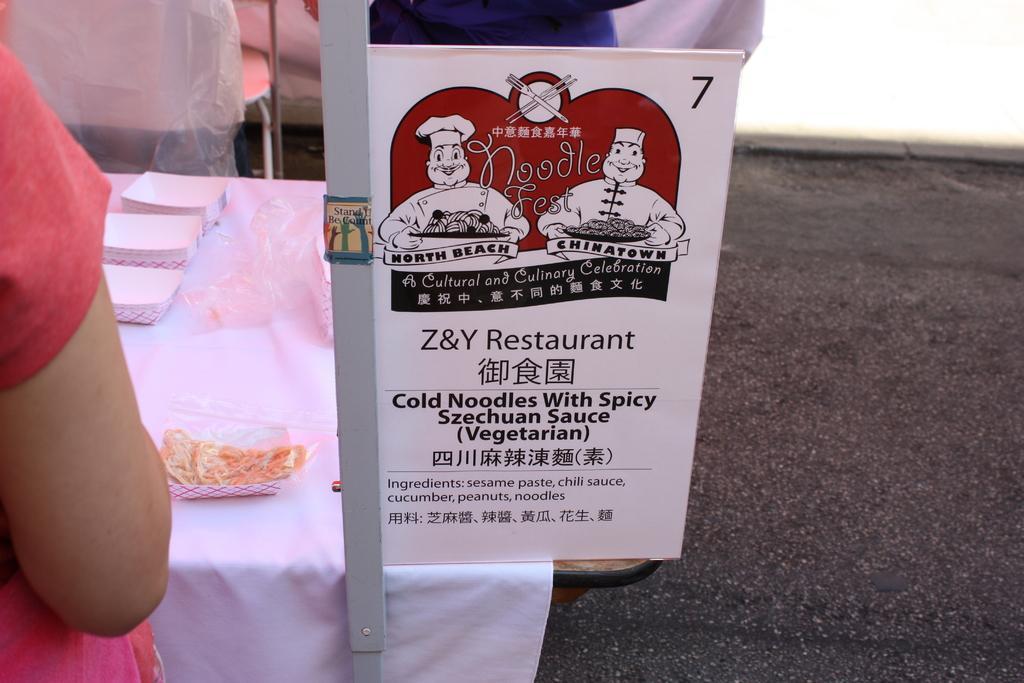Please provide a concise description of this image. In this picture I can see a board with some text, person hand in front of the table, on the table some objects are placed. 